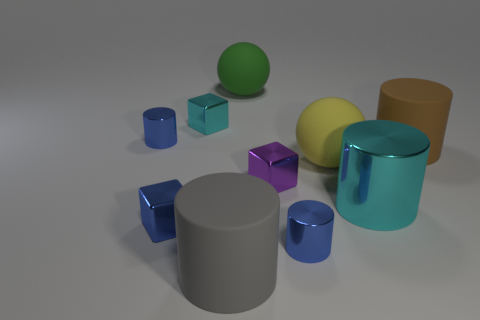Subtract all gray matte cylinders. How many cylinders are left? 4 Subtract all cyan cylinders. How many cylinders are left? 4 Subtract all brown cylinders. Subtract all blue blocks. How many cylinders are left? 4 Subtract all balls. How many objects are left? 8 Subtract all gray rubber cylinders. Subtract all cubes. How many objects are left? 6 Add 1 cyan cubes. How many cyan cubes are left? 2 Add 9 tiny red matte blocks. How many tiny red matte blocks exist? 9 Subtract 0 red spheres. How many objects are left? 10 